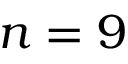Convert formula to latex. <formula><loc_0><loc_0><loc_500><loc_500>n = 9</formula> 